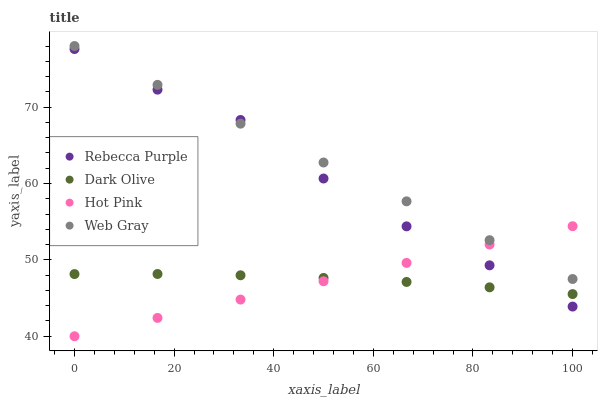Does Hot Pink have the minimum area under the curve?
Answer yes or no. Yes. Does Web Gray have the maximum area under the curve?
Answer yes or no. Yes. Does Rebecca Purple have the minimum area under the curve?
Answer yes or no. No. Does Rebecca Purple have the maximum area under the curve?
Answer yes or no. No. Is Hot Pink the smoothest?
Answer yes or no. Yes. Is Rebecca Purple the roughest?
Answer yes or no. Yes. Is Web Gray the smoothest?
Answer yes or no. No. Is Web Gray the roughest?
Answer yes or no. No. Does Hot Pink have the lowest value?
Answer yes or no. Yes. Does Rebecca Purple have the lowest value?
Answer yes or no. No. Does Web Gray have the highest value?
Answer yes or no. Yes. Does Rebecca Purple have the highest value?
Answer yes or no. No. Is Dark Olive less than Web Gray?
Answer yes or no. Yes. Is Web Gray greater than Dark Olive?
Answer yes or no. Yes. Does Web Gray intersect Rebecca Purple?
Answer yes or no. Yes. Is Web Gray less than Rebecca Purple?
Answer yes or no. No. Is Web Gray greater than Rebecca Purple?
Answer yes or no. No. Does Dark Olive intersect Web Gray?
Answer yes or no. No. 